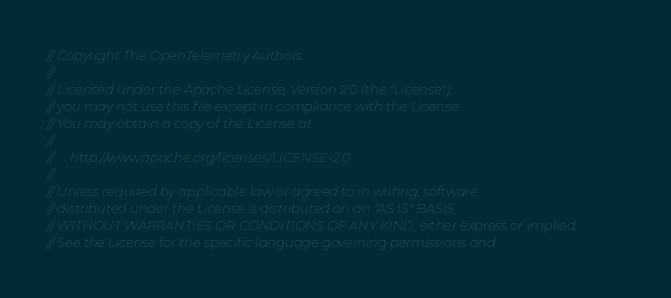<code> <loc_0><loc_0><loc_500><loc_500><_Go_>// Copyright The OpenTelemetry Authors
//
// Licensed under the Apache License, Version 2.0 (the "License");
// you may not use this file except in compliance with the License.
// You may obtain a copy of the License at
//
//     http://www.apache.org/licenses/LICENSE-2.0
//
// Unless required by applicable law or agreed to in writing, software
// distributed under the License is distributed on an "AS IS" BASIS,
// WITHOUT WARRANTIES OR CONDITIONS OF ANY KIND, either express or implied.
// See the License for the specific language governing permissions and</code> 